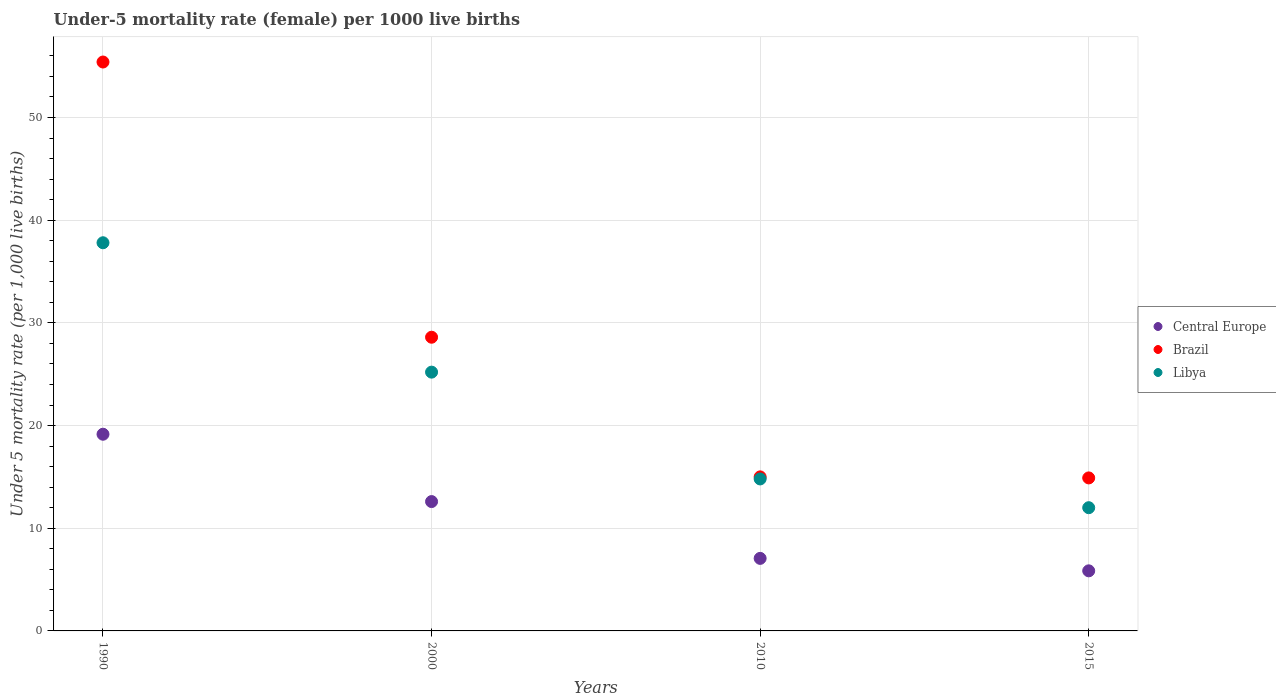How many different coloured dotlines are there?
Your answer should be very brief. 3. What is the under-five mortality rate in Libya in 1990?
Keep it short and to the point. 37.8. Across all years, what is the maximum under-five mortality rate in Central Europe?
Keep it short and to the point. 19.15. In which year was the under-five mortality rate in Libya maximum?
Offer a terse response. 1990. In which year was the under-five mortality rate in Central Europe minimum?
Provide a short and direct response. 2015. What is the total under-five mortality rate in Central Europe in the graph?
Offer a very short reply. 44.66. What is the difference between the under-five mortality rate in Brazil in 1990 and that in 2010?
Make the answer very short. 40.4. What is the average under-five mortality rate in Central Europe per year?
Your answer should be compact. 11.17. In the year 2015, what is the difference between the under-five mortality rate in Brazil and under-five mortality rate in Libya?
Make the answer very short. 2.9. In how many years, is the under-five mortality rate in Libya greater than 48?
Provide a short and direct response. 0. What is the ratio of the under-five mortality rate in Central Europe in 2000 to that in 2015?
Offer a terse response. 2.15. What is the difference between the highest and the second highest under-five mortality rate in Central Europe?
Provide a succinct answer. 6.56. What is the difference between the highest and the lowest under-five mortality rate in Libya?
Your answer should be compact. 25.8. Is the sum of the under-five mortality rate in Libya in 1990 and 2010 greater than the maximum under-five mortality rate in Brazil across all years?
Keep it short and to the point. No. Is it the case that in every year, the sum of the under-five mortality rate in Central Europe and under-five mortality rate in Brazil  is greater than the under-five mortality rate in Libya?
Offer a very short reply. Yes. Is the under-five mortality rate in Brazil strictly greater than the under-five mortality rate in Libya over the years?
Your response must be concise. Yes. How many dotlines are there?
Your answer should be compact. 3. How many years are there in the graph?
Your answer should be compact. 4. Are the values on the major ticks of Y-axis written in scientific E-notation?
Ensure brevity in your answer.  No. Does the graph contain grids?
Make the answer very short. Yes. How many legend labels are there?
Offer a terse response. 3. What is the title of the graph?
Ensure brevity in your answer.  Under-5 mortality rate (female) per 1000 live births. Does "Namibia" appear as one of the legend labels in the graph?
Ensure brevity in your answer.  No. What is the label or title of the X-axis?
Provide a succinct answer. Years. What is the label or title of the Y-axis?
Provide a succinct answer. Under 5 mortality rate (per 1,0 live births). What is the Under 5 mortality rate (per 1,000 live births) of Central Europe in 1990?
Provide a succinct answer. 19.15. What is the Under 5 mortality rate (per 1,000 live births) in Brazil in 1990?
Ensure brevity in your answer.  55.4. What is the Under 5 mortality rate (per 1,000 live births) in Libya in 1990?
Your answer should be very brief. 37.8. What is the Under 5 mortality rate (per 1,000 live births) in Central Europe in 2000?
Offer a very short reply. 12.6. What is the Under 5 mortality rate (per 1,000 live births) in Brazil in 2000?
Offer a very short reply. 28.6. What is the Under 5 mortality rate (per 1,000 live births) of Libya in 2000?
Your answer should be very brief. 25.2. What is the Under 5 mortality rate (per 1,000 live births) of Central Europe in 2010?
Give a very brief answer. 7.06. What is the Under 5 mortality rate (per 1,000 live births) of Libya in 2010?
Give a very brief answer. 14.8. What is the Under 5 mortality rate (per 1,000 live births) of Central Europe in 2015?
Offer a terse response. 5.85. What is the Under 5 mortality rate (per 1,000 live births) of Brazil in 2015?
Offer a terse response. 14.9. What is the Under 5 mortality rate (per 1,000 live births) of Libya in 2015?
Make the answer very short. 12. Across all years, what is the maximum Under 5 mortality rate (per 1,000 live births) of Central Europe?
Your response must be concise. 19.15. Across all years, what is the maximum Under 5 mortality rate (per 1,000 live births) of Brazil?
Offer a very short reply. 55.4. Across all years, what is the maximum Under 5 mortality rate (per 1,000 live births) of Libya?
Give a very brief answer. 37.8. Across all years, what is the minimum Under 5 mortality rate (per 1,000 live births) in Central Europe?
Give a very brief answer. 5.85. Across all years, what is the minimum Under 5 mortality rate (per 1,000 live births) in Libya?
Offer a terse response. 12. What is the total Under 5 mortality rate (per 1,000 live births) in Central Europe in the graph?
Your response must be concise. 44.66. What is the total Under 5 mortality rate (per 1,000 live births) in Brazil in the graph?
Ensure brevity in your answer.  113.9. What is the total Under 5 mortality rate (per 1,000 live births) of Libya in the graph?
Your answer should be compact. 89.8. What is the difference between the Under 5 mortality rate (per 1,000 live births) of Central Europe in 1990 and that in 2000?
Give a very brief answer. 6.56. What is the difference between the Under 5 mortality rate (per 1,000 live births) in Brazil in 1990 and that in 2000?
Your response must be concise. 26.8. What is the difference between the Under 5 mortality rate (per 1,000 live births) of Libya in 1990 and that in 2000?
Provide a succinct answer. 12.6. What is the difference between the Under 5 mortality rate (per 1,000 live births) of Central Europe in 1990 and that in 2010?
Your response must be concise. 12.09. What is the difference between the Under 5 mortality rate (per 1,000 live births) of Brazil in 1990 and that in 2010?
Provide a succinct answer. 40.4. What is the difference between the Under 5 mortality rate (per 1,000 live births) in Libya in 1990 and that in 2010?
Your answer should be compact. 23. What is the difference between the Under 5 mortality rate (per 1,000 live births) in Central Europe in 1990 and that in 2015?
Your response must be concise. 13.3. What is the difference between the Under 5 mortality rate (per 1,000 live births) in Brazil in 1990 and that in 2015?
Ensure brevity in your answer.  40.5. What is the difference between the Under 5 mortality rate (per 1,000 live births) of Libya in 1990 and that in 2015?
Your response must be concise. 25.8. What is the difference between the Under 5 mortality rate (per 1,000 live births) in Central Europe in 2000 and that in 2010?
Ensure brevity in your answer.  5.53. What is the difference between the Under 5 mortality rate (per 1,000 live births) of Central Europe in 2000 and that in 2015?
Give a very brief answer. 6.74. What is the difference between the Under 5 mortality rate (per 1,000 live births) in Brazil in 2000 and that in 2015?
Give a very brief answer. 13.7. What is the difference between the Under 5 mortality rate (per 1,000 live births) of Libya in 2000 and that in 2015?
Keep it short and to the point. 13.2. What is the difference between the Under 5 mortality rate (per 1,000 live births) in Central Europe in 2010 and that in 2015?
Your response must be concise. 1.21. What is the difference between the Under 5 mortality rate (per 1,000 live births) in Central Europe in 1990 and the Under 5 mortality rate (per 1,000 live births) in Brazil in 2000?
Your answer should be compact. -9.45. What is the difference between the Under 5 mortality rate (per 1,000 live births) in Central Europe in 1990 and the Under 5 mortality rate (per 1,000 live births) in Libya in 2000?
Provide a short and direct response. -6.05. What is the difference between the Under 5 mortality rate (per 1,000 live births) in Brazil in 1990 and the Under 5 mortality rate (per 1,000 live births) in Libya in 2000?
Offer a terse response. 30.2. What is the difference between the Under 5 mortality rate (per 1,000 live births) of Central Europe in 1990 and the Under 5 mortality rate (per 1,000 live births) of Brazil in 2010?
Ensure brevity in your answer.  4.15. What is the difference between the Under 5 mortality rate (per 1,000 live births) of Central Europe in 1990 and the Under 5 mortality rate (per 1,000 live births) of Libya in 2010?
Your answer should be very brief. 4.35. What is the difference between the Under 5 mortality rate (per 1,000 live births) of Brazil in 1990 and the Under 5 mortality rate (per 1,000 live births) of Libya in 2010?
Provide a succinct answer. 40.6. What is the difference between the Under 5 mortality rate (per 1,000 live births) of Central Europe in 1990 and the Under 5 mortality rate (per 1,000 live births) of Brazil in 2015?
Offer a very short reply. 4.25. What is the difference between the Under 5 mortality rate (per 1,000 live births) of Central Europe in 1990 and the Under 5 mortality rate (per 1,000 live births) of Libya in 2015?
Provide a succinct answer. 7.15. What is the difference between the Under 5 mortality rate (per 1,000 live births) in Brazil in 1990 and the Under 5 mortality rate (per 1,000 live births) in Libya in 2015?
Your response must be concise. 43.4. What is the difference between the Under 5 mortality rate (per 1,000 live births) of Central Europe in 2000 and the Under 5 mortality rate (per 1,000 live births) of Brazil in 2010?
Ensure brevity in your answer.  -2.4. What is the difference between the Under 5 mortality rate (per 1,000 live births) of Central Europe in 2000 and the Under 5 mortality rate (per 1,000 live births) of Libya in 2010?
Keep it short and to the point. -2.2. What is the difference between the Under 5 mortality rate (per 1,000 live births) of Central Europe in 2000 and the Under 5 mortality rate (per 1,000 live births) of Brazil in 2015?
Give a very brief answer. -2.3. What is the difference between the Under 5 mortality rate (per 1,000 live births) of Central Europe in 2000 and the Under 5 mortality rate (per 1,000 live births) of Libya in 2015?
Your answer should be very brief. 0.6. What is the difference between the Under 5 mortality rate (per 1,000 live births) in Central Europe in 2010 and the Under 5 mortality rate (per 1,000 live births) in Brazil in 2015?
Offer a terse response. -7.84. What is the difference between the Under 5 mortality rate (per 1,000 live births) in Central Europe in 2010 and the Under 5 mortality rate (per 1,000 live births) in Libya in 2015?
Provide a short and direct response. -4.94. What is the difference between the Under 5 mortality rate (per 1,000 live births) of Brazil in 2010 and the Under 5 mortality rate (per 1,000 live births) of Libya in 2015?
Give a very brief answer. 3. What is the average Under 5 mortality rate (per 1,000 live births) in Central Europe per year?
Ensure brevity in your answer.  11.17. What is the average Under 5 mortality rate (per 1,000 live births) of Brazil per year?
Offer a very short reply. 28.48. What is the average Under 5 mortality rate (per 1,000 live births) of Libya per year?
Your answer should be compact. 22.45. In the year 1990, what is the difference between the Under 5 mortality rate (per 1,000 live births) of Central Europe and Under 5 mortality rate (per 1,000 live births) of Brazil?
Your response must be concise. -36.25. In the year 1990, what is the difference between the Under 5 mortality rate (per 1,000 live births) of Central Europe and Under 5 mortality rate (per 1,000 live births) of Libya?
Offer a very short reply. -18.65. In the year 2000, what is the difference between the Under 5 mortality rate (per 1,000 live births) of Central Europe and Under 5 mortality rate (per 1,000 live births) of Brazil?
Your response must be concise. -16. In the year 2000, what is the difference between the Under 5 mortality rate (per 1,000 live births) of Central Europe and Under 5 mortality rate (per 1,000 live births) of Libya?
Provide a short and direct response. -12.6. In the year 2000, what is the difference between the Under 5 mortality rate (per 1,000 live births) in Brazil and Under 5 mortality rate (per 1,000 live births) in Libya?
Offer a terse response. 3.4. In the year 2010, what is the difference between the Under 5 mortality rate (per 1,000 live births) of Central Europe and Under 5 mortality rate (per 1,000 live births) of Brazil?
Provide a succinct answer. -7.94. In the year 2010, what is the difference between the Under 5 mortality rate (per 1,000 live births) of Central Europe and Under 5 mortality rate (per 1,000 live births) of Libya?
Make the answer very short. -7.74. In the year 2015, what is the difference between the Under 5 mortality rate (per 1,000 live births) of Central Europe and Under 5 mortality rate (per 1,000 live births) of Brazil?
Provide a short and direct response. -9.05. In the year 2015, what is the difference between the Under 5 mortality rate (per 1,000 live births) of Central Europe and Under 5 mortality rate (per 1,000 live births) of Libya?
Make the answer very short. -6.15. What is the ratio of the Under 5 mortality rate (per 1,000 live births) of Central Europe in 1990 to that in 2000?
Your answer should be very brief. 1.52. What is the ratio of the Under 5 mortality rate (per 1,000 live births) in Brazil in 1990 to that in 2000?
Provide a succinct answer. 1.94. What is the ratio of the Under 5 mortality rate (per 1,000 live births) of Central Europe in 1990 to that in 2010?
Provide a short and direct response. 2.71. What is the ratio of the Under 5 mortality rate (per 1,000 live births) of Brazil in 1990 to that in 2010?
Your response must be concise. 3.69. What is the ratio of the Under 5 mortality rate (per 1,000 live births) of Libya in 1990 to that in 2010?
Provide a succinct answer. 2.55. What is the ratio of the Under 5 mortality rate (per 1,000 live births) in Central Europe in 1990 to that in 2015?
Your answer should be very brief. 3.27. What is the ratio of the Under 5 mortality rate (per 1,000 live births) of Brazil in 1990 to that in 2015?
Offer a terse response. 3.72. What is the ratio of the Under 5 mortality rate (per 1,000 live births) of Libya in 1990 to that in 2015?
Your answer should be compact. 3.15. What is the ratio of the Under 5 mortality rate (per 1,000 live births) of Central Europe in 2000 to that in 2010?
Ensure brevity in your answer.  1.78. What is the ratio of the Under 5 mortality rate (per 1,000 live births) in Brazil in 2000 to that in 2010?
Ensure brevity in your answer.  1.91. What is the ratio of the Under 5 mortality rate (per 1,000 live births) in Libya in 2000 to that in 2010?
Offer a very short reply. 1.7. What is the ratio of the Under 5 mortality rate (per 1,000 live births) of Central Europe in 2000 to that in 2015?
Keep it short and to the point. 2.15. What is the ratio of the Under 5 mortality rate (per 1,000 live births) of Brazil in 2000 to that in 2015?
Offer a terse response. 1.92. What is the ratio of the Under 5 mortality rate (per 1,000 live births) of Central Europe in 2010 to that in 2015?
Provide a short and direct response. 1.21. What is the ratio of the Under 5 mortality rate (per 1,000 live births) in Brazil in 2010 to that in 2015?
Provide a short and direct response. 1.01. What is the ratio of the Under 5 mortality rate (per 1,000 live births) of Libya in 2010 to that in 2015?
Your answer should be compact. 1.23. What is the difference between the highest and the second highest Under 5 mortality rate (per 1,000 live births) in Central Europe?
Make the answer very short. 6.56. What is the difference between the highest and the second highest Under 5 mortality rate (per 1,000 live births) of Brazil?
Offer a very short reply. 26.8. What is the difference between the highest and the second highest Under 5 mortality rate (per 1,000 live births) of Libya?
Give a very brief answer. 12.6. What is the difference between the highest and the lowest Under 5 mortality rate (per 1,000 live births) in Central Europe?
Your response must be concise. 13.3. What is the difference between the highest and the lowest Under 5 mortality rate (per 1,000 live births) of Brazil?
Make the answer very short. 40.5. What is the difference between the highest and the lowest Under 5 mortality rate (per 1,000 live births) of Libya?
Your response must be concise. 25.8. 